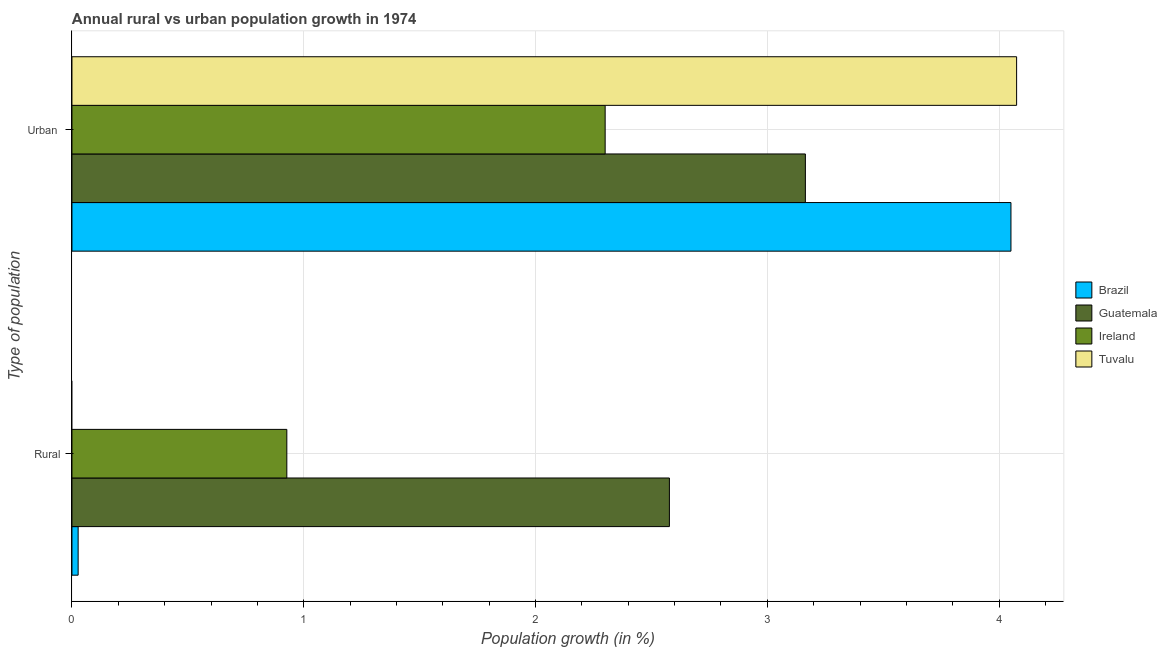How many different coloured bars are there?
Offer a very short reply. 4. Are the number of bars per tick equal to the number of legend labels?
Your response must be concise. No. Are the number of bars on each tick of the Y-axis equal?
Your answer should be compact. No. How many bars are there on the 1st tick from the top?
Provide a succinct answer. 4. How many bars are there on the 2nd tick from the bottom?
Ensure brevity in your answer.  4. What is the label of the 1st group of bars from the top?
Your answer should be very brief. Urban . What is the urban population growth in Ireland?
Offer a very short reply. 2.3. Across all countries, what is the maximum urban population growth?
Ensure brevity in your answer.  4.08. Across all countries, what is the minimum rural population growth?
Make the answer very short. 0. In which country was the urban population growth maximum?
Your response must be concise. Tuvalu. What is the total rural population growth in the graph?
Make the answer very short. 3.53. What is the difference between the rural population growth in Ireland and that in Guatemala?
Keep it short and to the point. -1.65. What is the difference between the urban population growth in Brazil and the rural population growth in Ireland?
Keep it short and to the point. 3.12. What is the average urban population growth per country?
Your answer should be compact. 3.4. What is the difference between the rural population growth and urban population growth in Brazil?
Make the answer very short. -4.02. What is the ratio of the rural population growth in Guatemala to that in Brazil?
Your answer should be very brief. 96.61. In how many countries, is the urban population growth greater than the average urban population growth taken over all countries?
Offer a very short reply. 2. How many bars are there?
Offer a terse response. 7. Are all the bars in the graph horizontal?
Keep it short and to the point. Yes. How many countries are there in the graph?
Provide a succinct answer. 4. What is the difference between two consecutive major ticks on the X-axis?
Provide a short and direct response. 1. Does the graph contain any zero values?
Your response must be concise. Yes. Does the graph contain grids?
Offer a terse response. Yes. Where does the legend appear in the graph?
Ensure brevity in your answer.  Center right. How many legend labels are there?
Ensure brevity in your answer.  4. What is the title of the graph?
Make the answer very short. Annual rural vs urban population growth in 1974. What is the label or title of the X-axis?
Provide a short and direct response. Population growth (in %). What is the label or title of the Y-axis?
Your response must be concise. Type of population. What is the Population growth (in %) in Brazil in Rural?
Give a very brief answer. 0.03. What is the Population growth (in %) of Guatemala in Rural?
Make the answer very short. 2.58. What is the Population growth (in %) of Ireland in Rural?
Provide a succinct answer. 0.93. What is the Population growth (in %) in Tuvalu in Rural?
Keep it short and to the point. 0. What is the Population growth (in %) of Brazil in Urban ?
Keep it short and to the point. 4.05. What is the Population growth (in %) in Guatemala in Urban ?
Make the answer very short. 3.16. What is the Population growth (in %) of Ireland in Urban ?
Keep it short and to the point. 2.3. What is the Population growth (in %) of Tuvalu in Urban ?
Ensure brevity in your answer.  4.08. Across all Type of population, what is the maximum Population growth (in %) of Brazil?
Offer a terse response. 4.05. Across all Type of population, what is the maximum Population growth (in %) of Guatemala?
Provide a short and direct response. 3.16. Across all Type of population, what is the maximum Population growth (in %) in Ireland?
Ensure brevity in your answer.  2.3. Across all Type of population, what is the maximum Population growth (in %) of Tuvalu?
Offer a terse response. 4.08. Across all Type of population, what is the minimum Population growth (in %) in Brazil?
Your answer should be compact. 0.03. Across all Type of population, what is the minimum Population growth (in %) of Guatemala?
Offer a terse response. 2.58. Across all Type of population, what is the minimum Population growth (in %) in Ireland?
Your answer should be compact. 0.93. Across all Type of population, what is the minimum Population growth (in %) in Tuvalu?
Your response must be concise. 0. What is the total Population growth (in %) in Brazil in the graph?
Make the answer very short. 4.08. What is the total Population growth (in %) in Guatemala in the graph?
Your answer should be compact. 5.74. What is the total Population growth (in %) in Ireland in the graph?
Offer a terse response. 3.23. What is the total Population growth (in %) in Tuvalu in the graph?
Your answer should be very brief. 4.08. What is the difference between the Population growth (in %) in Brazil in Rural and that in Urban ?
Provide a short and direct response. -4.02. What is the difference between the Population growth (in %) of Guatemala in Rural and that in Urban ?
Provide a succinct answer. -0.59. What is the difference between the Population growth (in %) of Ireland in Rural and that in Urban ?
Provide a short and direct response. -1.37. What is the difference between the Population growth (in %) in Brazil in Rural and the Population growth (in %) in Guatemala in Urban ?
Keep it short and to the point. -3.14. What is the difference between the Population growth (in %) of Brazil in Rural and the Population growth (in %) of Ireland in Urban ?
Your answer should be very brief. -2.27. What is the difference between the Population growth (in %) of Brazil in Rural and the Population growth (in %) of Tuvalu in Urban ?
Ensure brevity in your answer.  -4.05. What is the difference between the Population growth (in %) of Guatemala in Rural and the Population growth (in %) of Ireland in Urban ?
Make the answer very short. 0.28. What is the difference between the Population growth (in %) in Guatemala in Rural and the Population growth (in %) in Tuvalu in Urban ?
Ensure brevity in your answer.  -1.5. What is the difference between the Population growth (in %) in Ireland in Rural and the Population growth (in %) in Tuvalu in Urban ?
Ensure brevity in your answer.  -3.15. What is the average Population growth (in %) of Brazil per Type of population?
Give a very brief answer. 2.04. What is the average Population growth (in %) of Guatemala per Type of population?
Keep it short and to the point. 2.87. What is the average Population growth (in %) in Ireland per Type of population?
Offer a terse response. 1.61. What is the average Population growth (in %) in Tuvalu per Type of population?
Offer a terse response. 2.04. What is the difference between the Population growth (in %) of Brazil and Population growth (in %) of Guatemala in Rural?
Your answer should be compact. -2.55. What is the difference between the Population growth (in %) of Brazil and Population growth (in %) of Ireland in Rural?
Make the answer very short. -0.9. What is the difference between the Population growth (in %) of Guatemala and Population growth (in %) of Ireland in Rural?
Your response must be concise. 1.65. What is the difference between the Population growth (in %) in Brazil and Population growth (in %) in Guatemala in Urban ?
Give a very brief answer. 0.89. What is the difference between the Population growth (in %) of Brazil and Population growth (in %) of Ireland in Urban ?
Keep it short and to the point. 1.75. What is the difference between the Population growth (in %) of Brazil and Population growth (in %) of Tuvalu in Urban ?
Your response must be concise. -0.02. What is the difference between the Population growth (in %) of Guatemala and Population growth (in %) of Ireland in Urban ?
Your answer should be compact. 0.86. What is the difference between the Population growth (in %) in Guatemala and Population growth (in %) in Tuvalu in Urban ?
Offer a very short reply. -0.91. What is the difference between the Population growth (in %) in Ireland and Population growth (in %) in Tuvalu in Urban ?
Offer a very short reply. -1.78. What is the ratio of the Population growth (in %) in Brazil in Rural to that in Urban ?
Offer a terse response. 0.01. What is the ratio of the Population growth (in %) in Guatemala in Rural to that in Urban ?
Your answer should be very brief. 0.81. What is the ratio of the Population growth (in %) in Ireland in Rural to that in Urban ?
Provide a succinct answer. 0.4. What is the difference between the highest and the second highest Population growth (in %) of Brazil?
Make the answer very short. 4.02. What is the difference between the highest and the second highest Population growth (in %) in Guatemala?
Keep it short and to the point. 0.59. What is the difference between the highest and the second highest Population growth (in %) in Ireland?
Give a very brief answer. 1.37. What is the difference between the highest and the lowest Population growth (in %) of Brazil?
Keep it short and to the point. 4.02. What is the difference between the highest and the lowest Population growth (in %) in Guatemala?
Give a very brief answer. 0.59. What is the difference between the highest and the lowest Population growth (in %) of Ireland?
Your answer should be very brief. 1.37. What is the difference between the highest and the lowest Population growth (in %) in Tuvalu?
Keep it short and to the point. 4.08. 